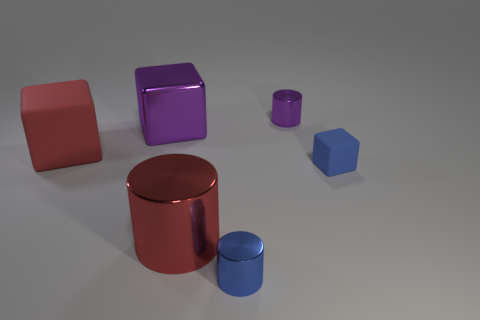Subtract all blue blocks. How many blocks are left? 2 Subtract all red cubes. How many cubes are left? 2 Subtract 1 cylinders. How many cylinders are left? 2 Add 2 big red matte objects. How many objects exist? 8 Add 1 rubber things. How many rubber things exist? 3 Subtract 0 green blocks. How many objects are left? 6 Subtract all cyan cubes. Subtract all gray spheres. How many cubes are left? 3 Subtract all blue blocks. How many purple cylinders are left? 1 Subtract all small shiny blocks. Subtract all tiny objects. How many objects are left? 3 Add 5 small metallic objects. How many small metallic objects are left? 7 